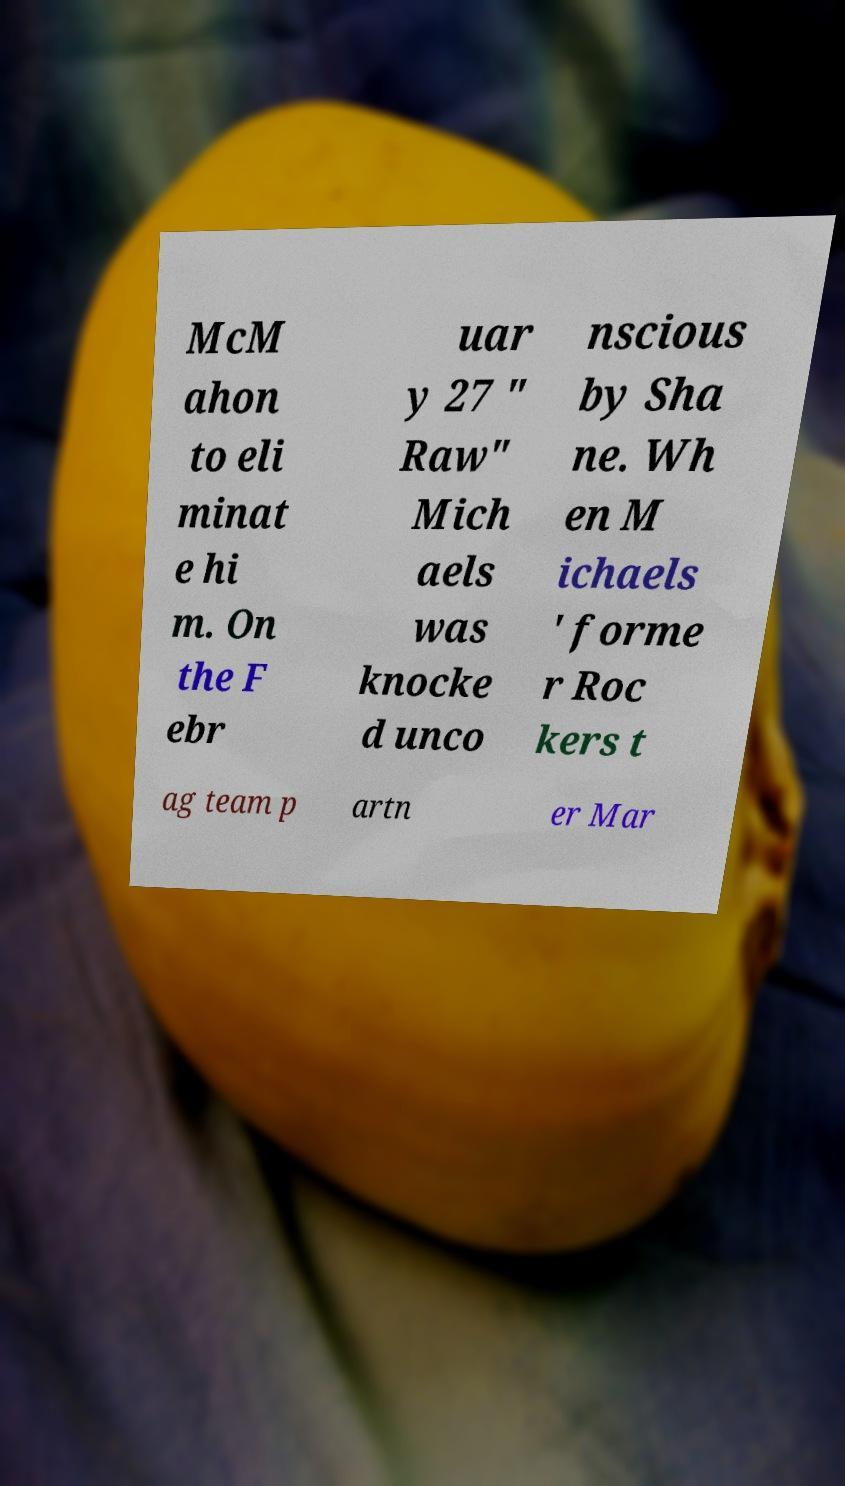For documentation purposes, I need the text within this image transcribed. Could you provide that? McM ahon to eli minat e hi m. On the F ebr uar y 27 " Raw" Mich aels was knocke d unco nscious by Sha ne. Wh en M ichaels ' forme r Roc kers t ag team p artn er Mar 